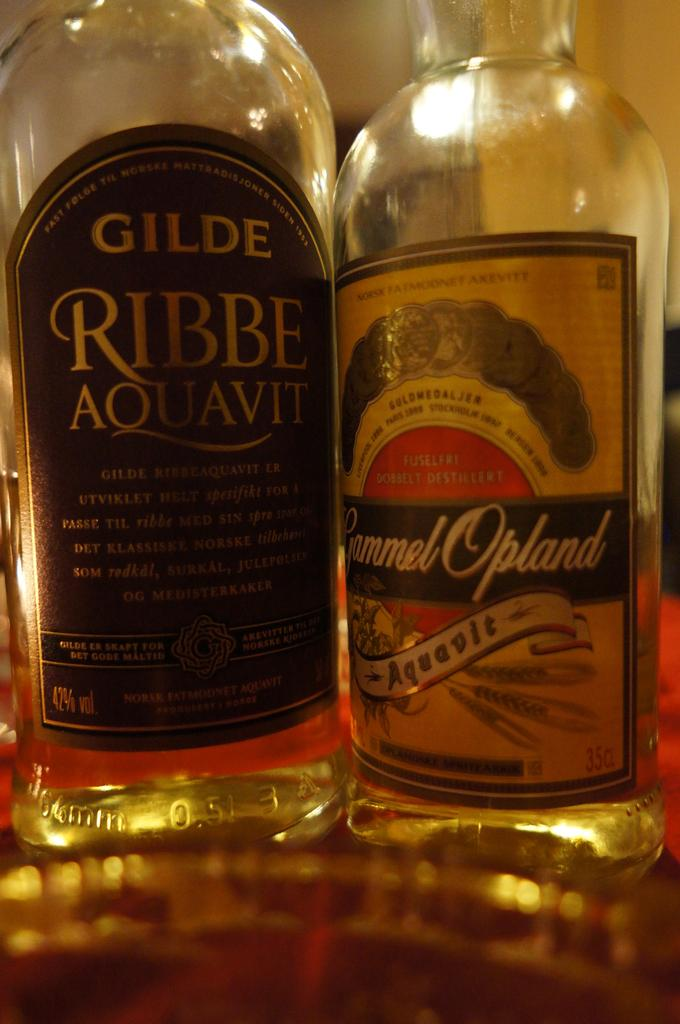<image>
Render a clear and concise summary of the photo. Two bottles next to each other of Aouavit 